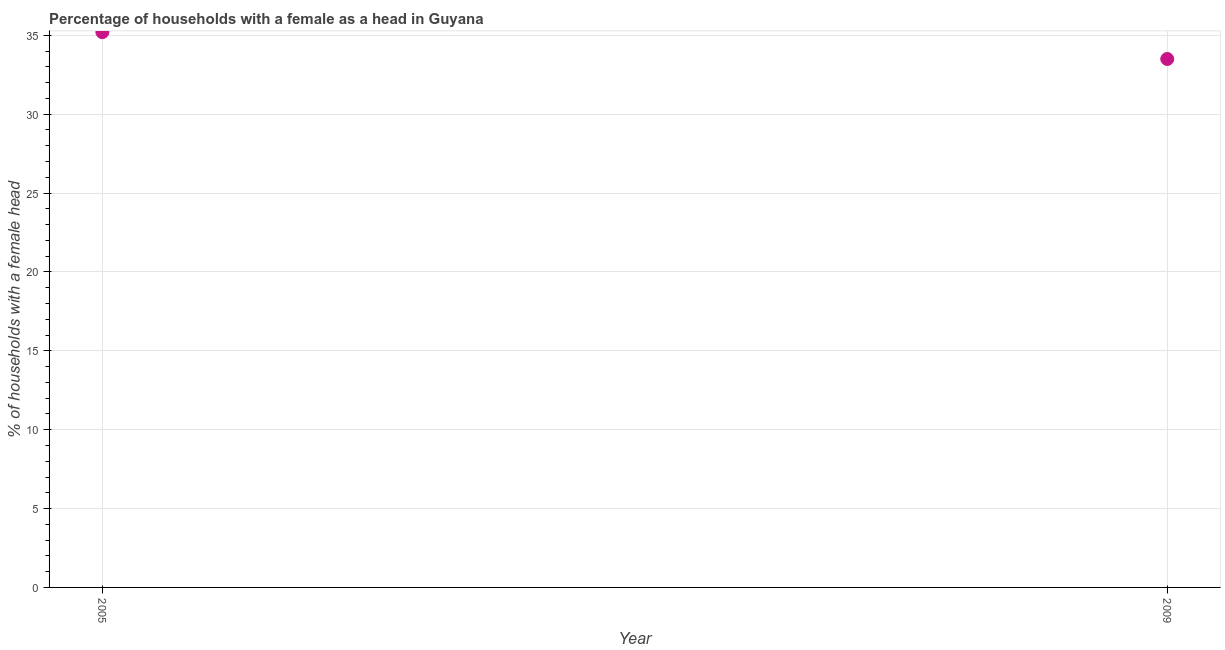What is the number of female supervised households in 2009?
Provide a short and direct response. 33.5. Across all years, what is the maximum number of female supervised households?
Your answer should be very brief. 35.2. Across all years, what is the minimum number of female supervised households?
Your answer should be very brief. 33.5. In which year was the number of female supervised households maximum?
Your response must be concise. 2005. In which year was the number of female supervised households minimum?
Offer a terse response. 2009. What is the sum of the number of female supervised households?
Your response must be concise. 68.7. What is the difference between the number of female supervised households in 2005 and 2009?
Offer a very short reply. 1.7. What is the average number of female supervised households per year?
Give a very brief answer. 34.35. What is the median number of female supervised households?
Provide a short and direct response. 34.35. In how many years, is the number of female supervised households greater than 30 %?
Your answer should be very brief. 2. Do a majority of the years between 2005 and 2009 (inclusive) have number of female supervised households greater than 20 %?
Your answer should be compact. Yes. What is the ratio of the number of female supervised households in 2005 to that in 2009?
Provide a short and direct response. 1.05. Is the number of female supervised households in 2005 less than that in 2009?
Provide a short and direct response. No. In how many years, is the number of female supervised households greater than the average number of female supervised households taken over all years?
Provide a succinct answer. 1. What is the difference between two consecutive major ticks on the Y-axis?
Provide a succinct answer. 5. Are the values on the major ticks of Y-axis written in scientific E-notation?
Offer a very short reply. No. Does the graph contain any zero values?
Provide a succinct answer. No. Does the graph contain grids?
Give a very brief answer. Yes. What is the title of the graph?
Make the answer very short. Percentage of households with a female as a head in Guyana. What is the label or title of the Y-axis?
Keep it short and to the point. % of households with a female head. What is the % of households with a female head in 2005?
Provide a short and direct response. 35.2. What is the % of households with a female head in 2009?
Keep it short and to the point. 33.5. What is the difference between the % of households with a female head in 2005 and 2009?
Offer a terse response. 1.7. What is the ratio of the % of households with a female head in 2005 to that in 2009?
Ensure brevity in your answer.  1.05. 